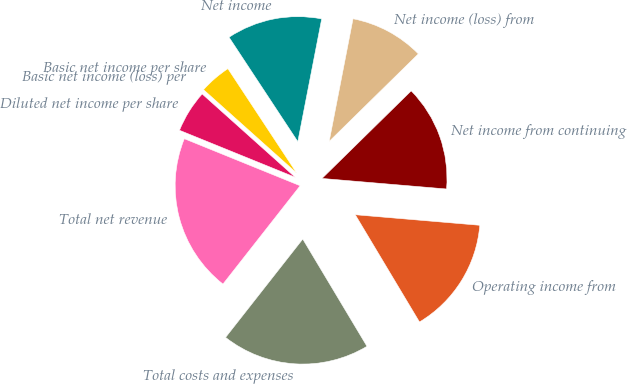Convert chart to OTSL. <chart><loc_0><loc_0><loc_500><loc_500><pie_chart><fcel>Total net revenue<fcel>Total costs and expenses<fcel>Operating income from<fcel>Net income from continuing<fcel>Net income (loss) from<fcel>Net income<fcel>Basic net income per share<fcel>Basic net income (loss) per<fcel>Diluted net income per share<nl><fcel>20.55%<fcel>19.18%<fcel>15.07%<fcel>13.7%<fcel>9.59%<fcel>12.33%<fcel>4.11%<fcel>0.0%<fcel>5.48%<nl></chart> 